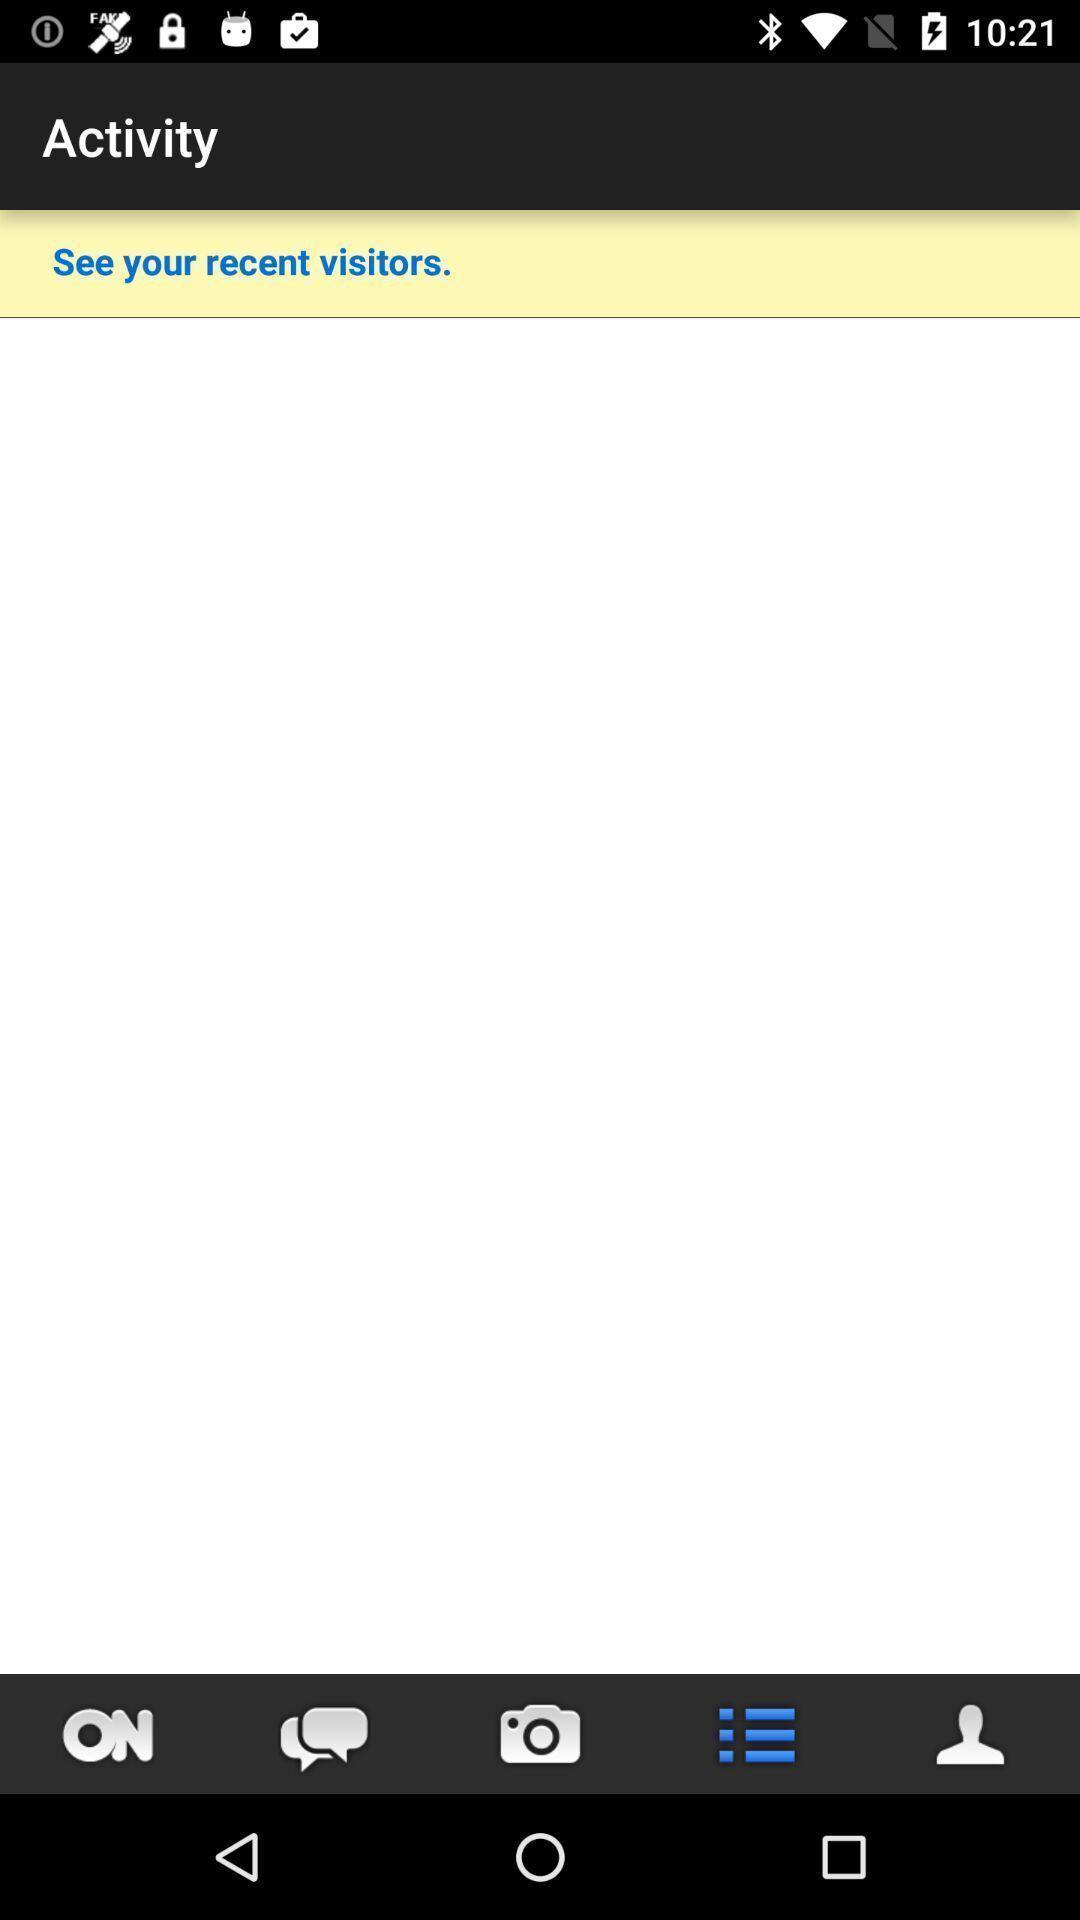Summarize the main components in this picture. Screen displaying multiple icons in an activity page. 